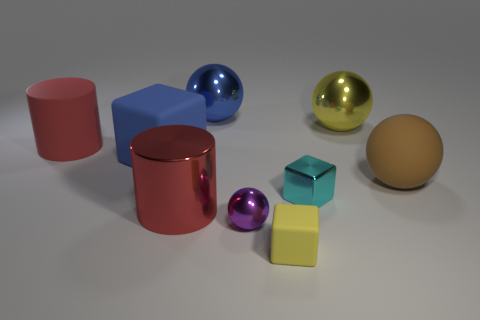How would this collection of objects look in a real-world setting? In a real-world setting, these objects might resemble a display of designer home decor items or educational models used to demonstrate geometric shapes. Their pristine condition and the simple background give a studio-like or instructional feel to the image. 